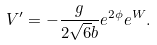<formula> <loc_0><loc_0><loc_500><loc_500>V ^ { \prime } = - { \frac { g } { 2 \sqrt { 6 } b } } e ^ { 2 \phi } e ^ { W } .</formula> 